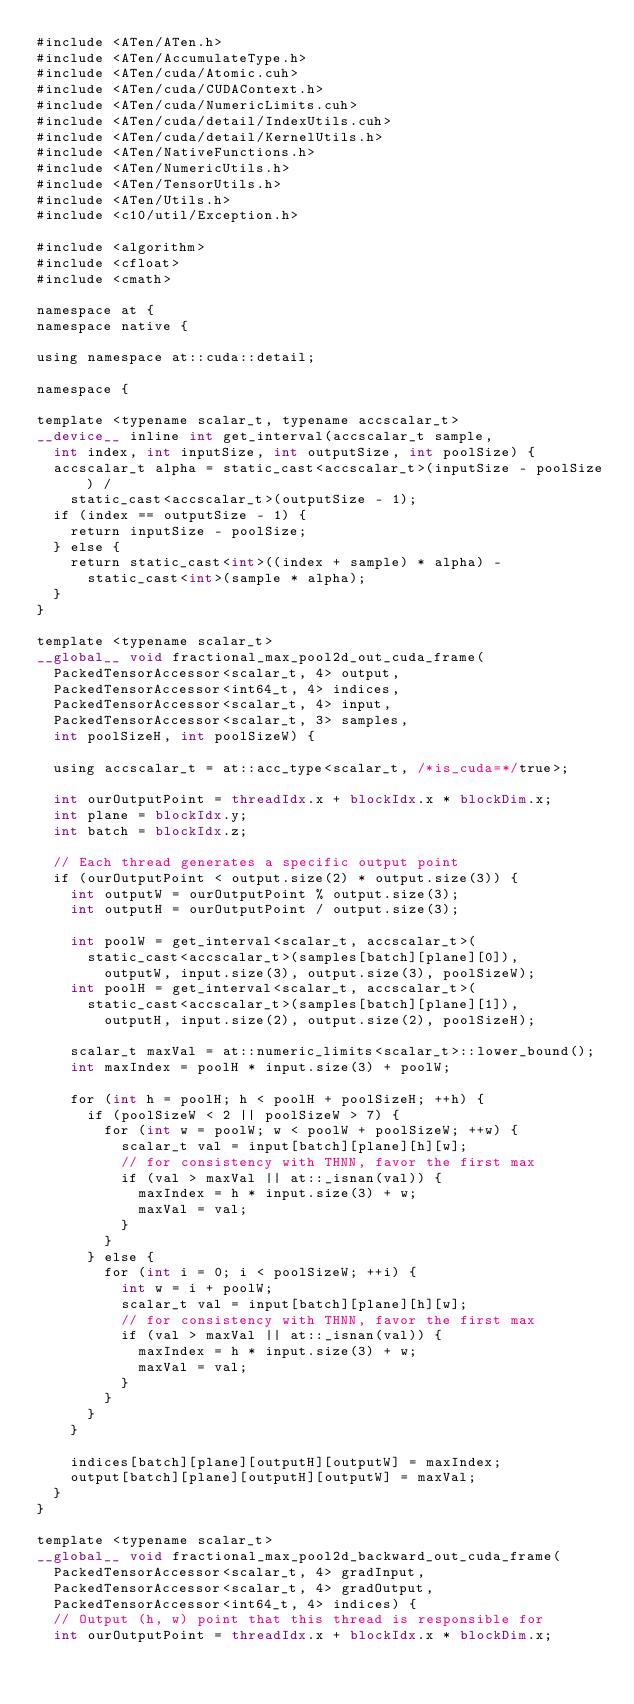Convert code to text. <code><loc_0><loc_0><loc_500><loc_500><_Cuda_>#include <ATen/ATen.h>
#include <ATen/AccumulateType.h>
#include <ATen/cuda/Atomic.cuh>
#include <ATen/cuda/CUDAContext.h>
#include <ATen/cuda/NumericLimits.cuh>
#include <ATen/cuda/detail/IndexUtils.cuh>
#include <ATen/cuda/detail/KernelUtils.h>
#include <ATen/NativeFunctions.h>
#include <ATen/NumericUtils.h>
#include <ATen/TensorUtils.h>
#include <ATen/Utils.h>
#include <c10/util/Exception.h>

#include <algorithm>
#include <cfloat>
#include <cmath>

namespace at {
namespace native {

using namespace at::cuda::detail;

namespace {

template <typename scalar_t, typename accscalar_t>
__device__ inline int get_interval(accscalar_t sample,
  int index, int inputSize, int outputSize, int poolSize) {
  accscalar_t alpha = static_cast<accscalar_t>(inputSize - poolSize) /
    static_cast<accscalar_t>(outputSize - 1);
  if (index == outputSize - 1) {
    return inputSize - poolSize;
  } else {
    return static_cast<int>((index + sample) * alpha) -
      static_cast<int>(sample * alpha);
  }
}

template <typename scalar_t>
__global__ void fractional_max_pool2d_out_cuda_frame(
  PackedTensorAccessor<scalar_t, 4> output,
  PackedTensorAccessor<int64_t, 4> indices,
  PackedTensorAccessor<scalar_t, 4> input,
  PackedTensorAccessor<scalar_t, 3> samples,
  int poolSizeH, int poolSizeW) {

  using accscalar_t = at::acc_type<scalar_t, /*is_cuda=*/true>;

  int ourOutputPoint = threadIdx.x + blockIdx.x * blockDim.x;
  int plane = blockIdx.y;
  int batch = blockIdx.z;

  // Each thread generates a specific output point
  if (ourOutputPoint < output.size(2) * output.size(3)) {
    int outputW = ourOutputPoint % output.size(3);
    int outputH = ourOutputPoint / output.size(3);

    int poolW = get_interval<scalar_t, accscalar_t>(
      static_cast<accscalar_t>(samples[batch][plane][0]),
        outputW, input.size(3), output.size(3), poolSizeW);
    int poolH = get_interval<scalar_t, accscalar_t>(
      static_cast<accscalar_t>(samples[batch][plane][1]),
        outputH, input.size(2), output.size(2), poolSizeH);

    scalar_t maxVal = at::numeric_limits<scalar_t>::lower_bound();
    int maxIndex = poolH * input.size(3) + poolW;

    for (int h = poolH; h < poolH + poolSizeH; ++h) {
      if (poolSizeW < 2 || poolSizeW > 7) {
        for (int w = poolW; w < poolW + poolSizeW; ++w) {
          scalar_t val = input[batch][plane][h][w];
          // for consistency with THNN, favor the first max
          if (val > maxVal || at::_isnan(val)) {
            maxIndex = h * input.size(3) + w;
            maxVal = val;
          }
        }
      } else {
        for (int i = 0; i < poolSizeW; ++i) {
          int w = i + poolW;
          scalar_t val = input[batch][plane][h][w];
          // for consistency with THNN, favor the first max
          if (val > maxVal || at::_isnan(val)) {
            maxIndex = h * input.size(3) + w;
            maxVal = val;
          }
        }
      }
    }

    indices[batch][plane][outputH][outputW] = maxIndex;
    output[batch][plane][outputH][outputW] = maxVal;
  }
}

template <typename scalar_t>
__global__ void fractional_max_pool2d_backward_out_cuda_frame(
  PackedTensorAccessor<scalar_t, 4> gradInput,
  PackedTensorAccessor<scalar_t, 4> gradOutput,
  PackedTensorAccessor<int64_t, 4> indices) {
  // Output (h, w) point that this thread is responsible for
  int ourOutputPoint = threadIdx.x + blockIdx.x * blockDim.x;</code> 